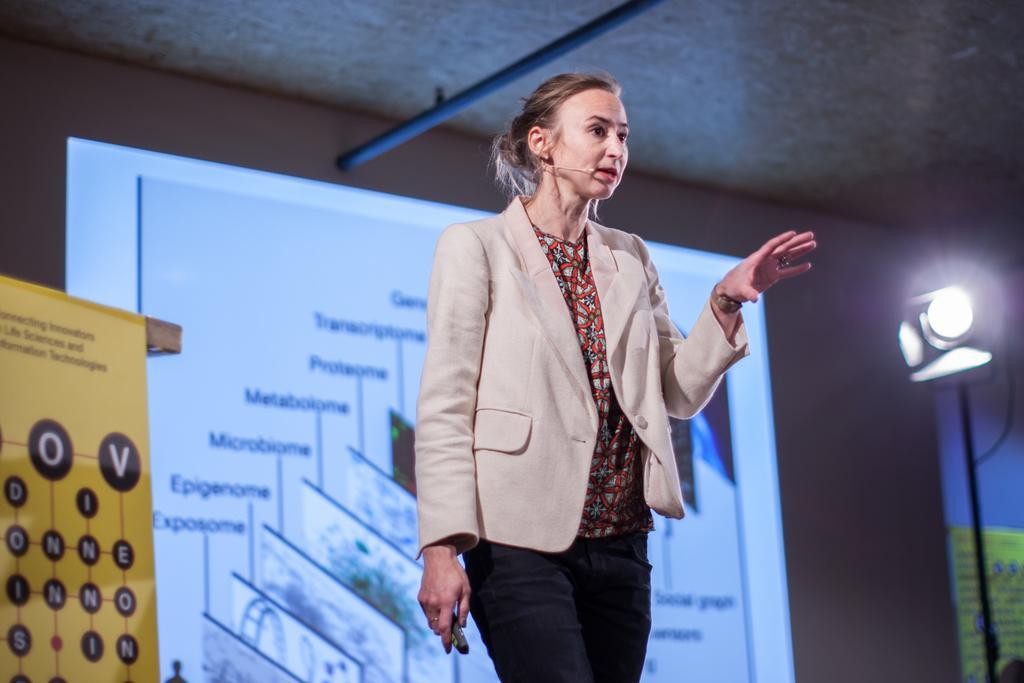In one or two sentences, can you explain what this image depicts? In this image we can see a person holding an object and there is a presentation screen in the background, there is a light with pole on the right side, there is a poster on the left side and a rod on the top. 